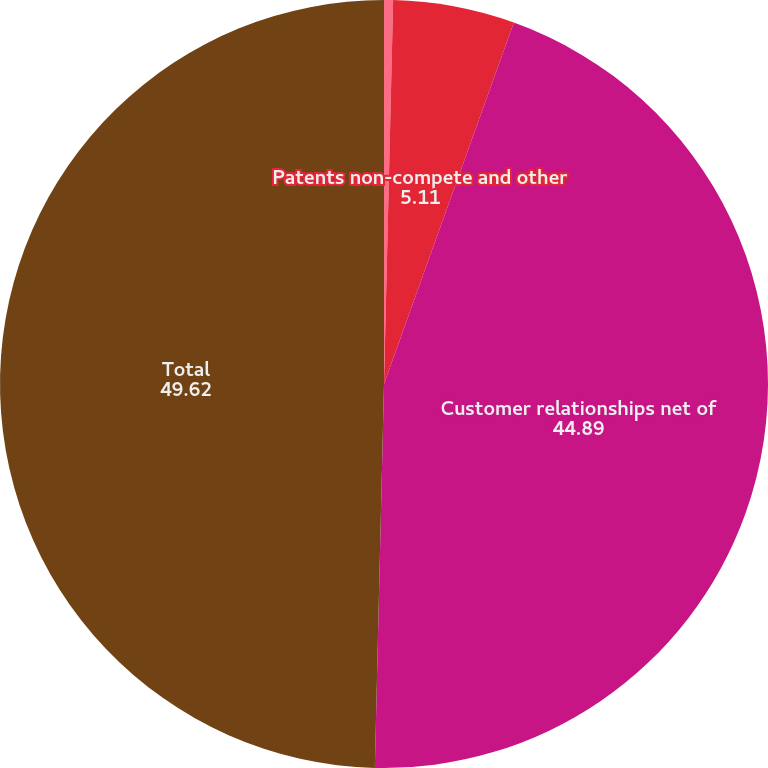Convert chart. <chart><loc_0><loc_0><loc_500><loc_500><pie_chart><fcel>In thousands<fcel>Patents non-compete and other<fcel>Customer relationships net of<fcel>Total<nl><fcel>0.38%<fcel>5.11%<fcel>44.89%<fcel>49.62%<nl></chart> 